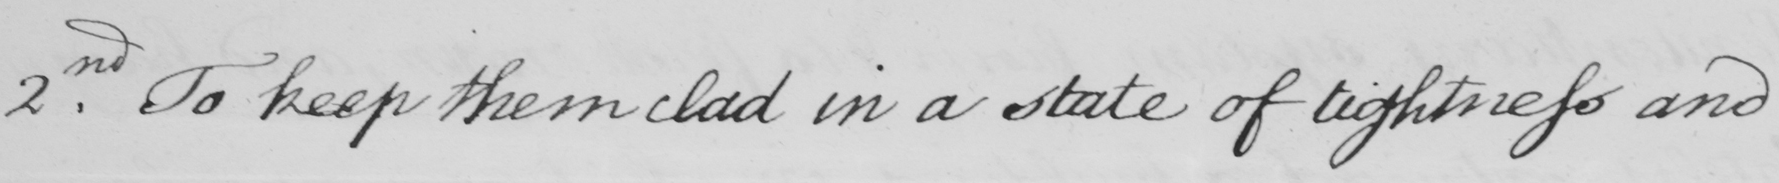What text is written in this handwritten line? 2nd. To keep them clad in state of lightness and 